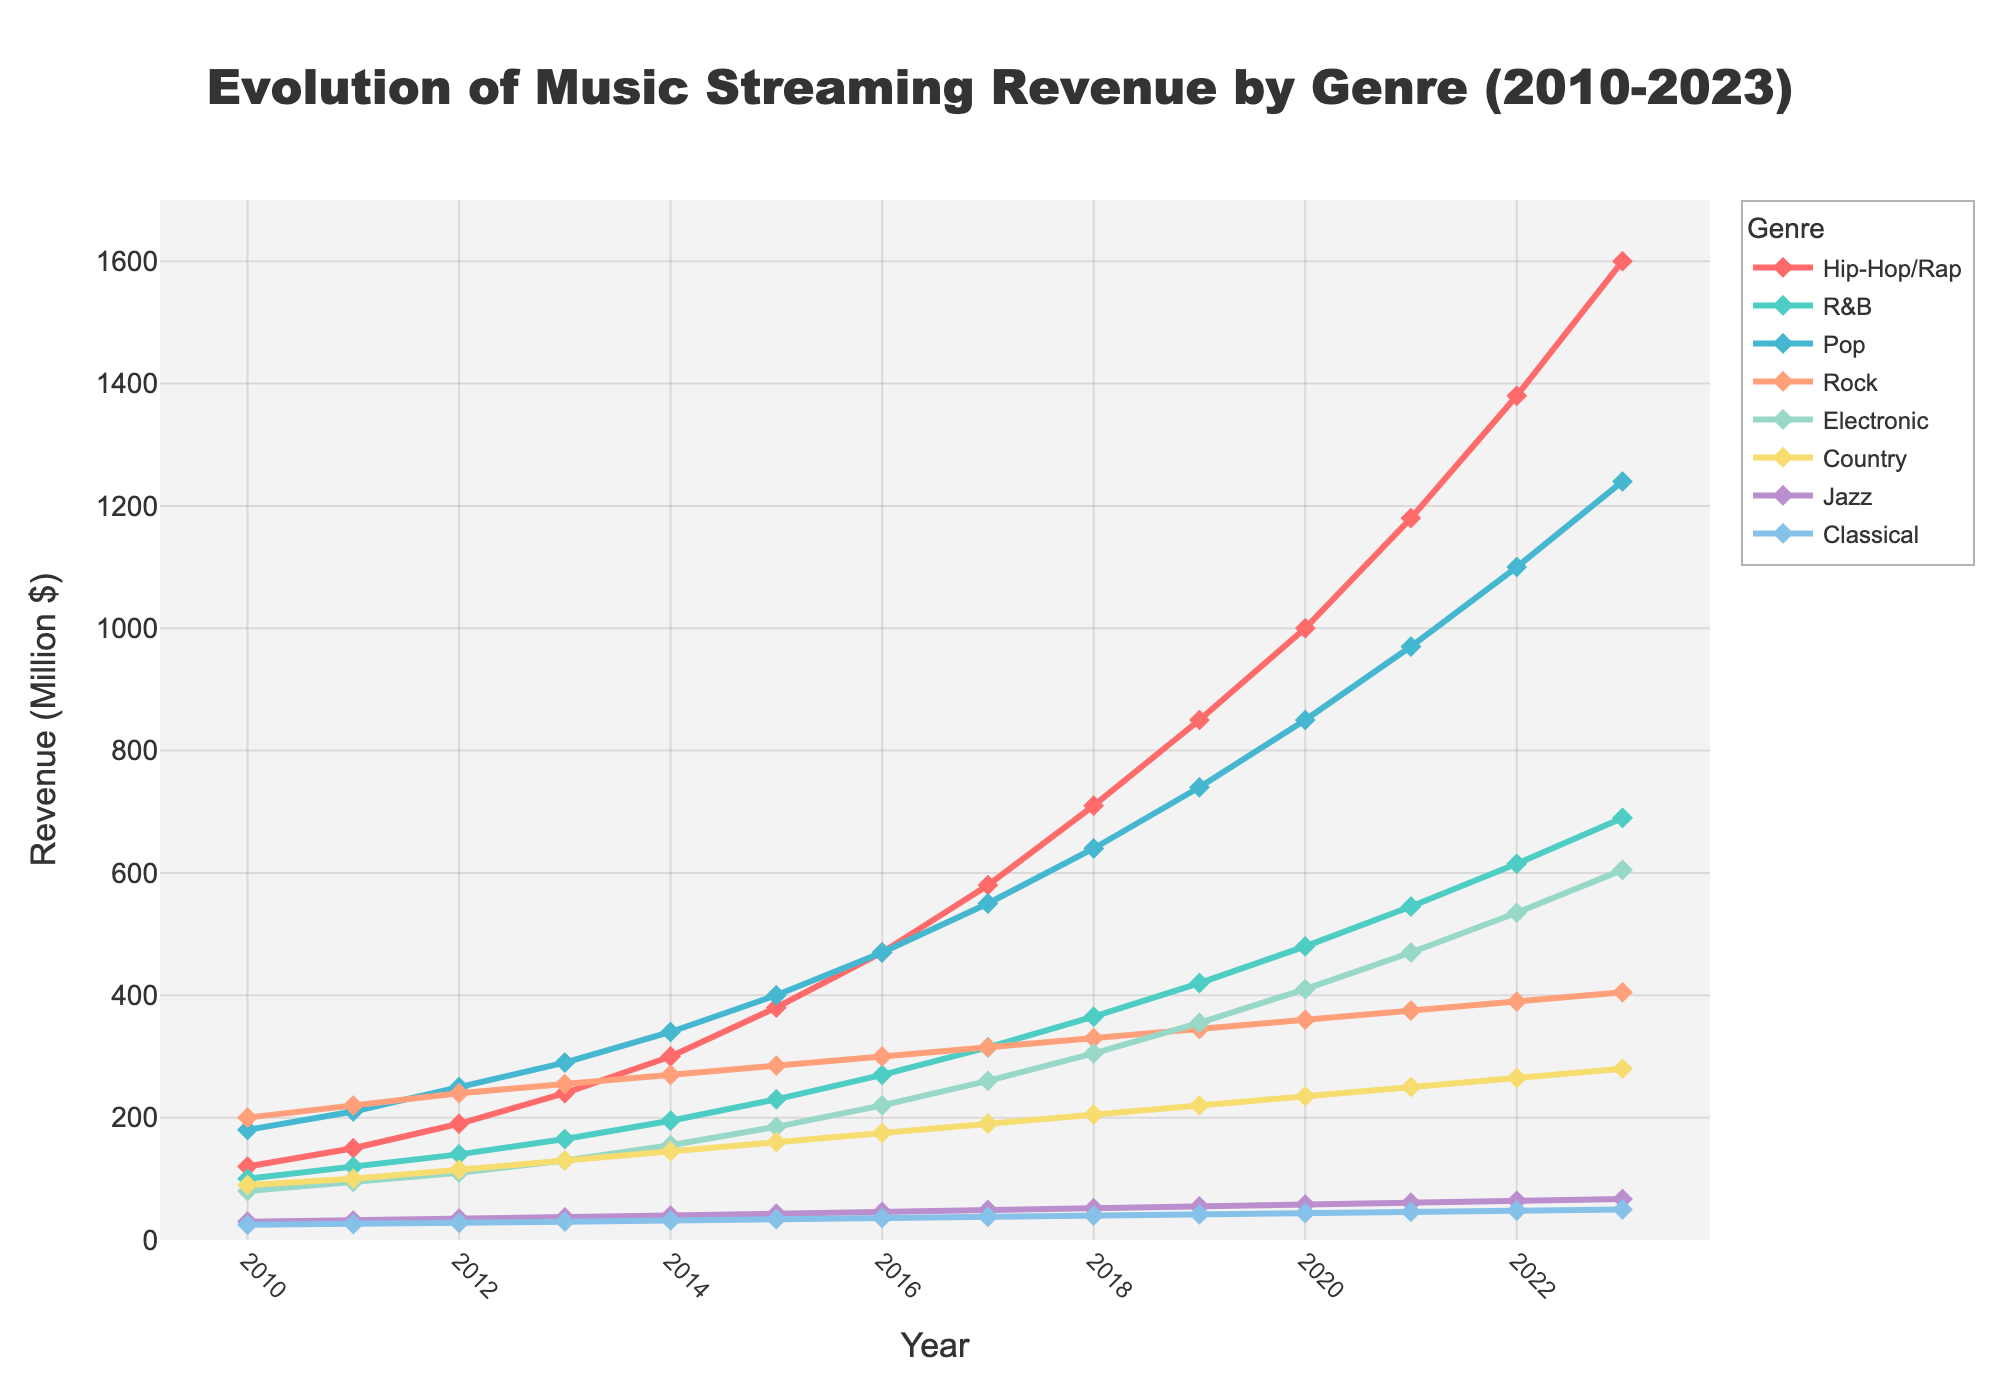Which genre had the highest revenue in 2023? By looking at the figure for 2023, observe which line reaches the highest point. Hip-Hop/Rap's line is the highest.
Answer: Hip-Hop/Rap Which genre showed the most significant increase in revenue from 2010 to 2023? Compare the 2010 and 2023 data points for each genre to find the largest difference. Hip-Hop/Rap increased from 120 million to 1600 million dollars, the largest of any genre.
Answer: Hip-Hop/Rap How did the revenue of Rock music change between 2017 and 2019? Compare the Rock genre's revenue at 2017 and 2019. In 2017 it was 315 million, and in 2019 it was 345 million.
Answer: Increased by 30 million What is the average revenue of Pop music over the years 2010, 2015, and 2020? Calculate (180 + 400 + 850) / 3. Sum is 1430 and division by 3 results in approximately 476.67.
Answer: Approximately 476.67 million dollars Which genre had the smallest revenue in 2010? Look for the lowest line or point in 2010. Classical had the smallest revenue at 25 million dollars.
Answer: Classical In which year did Electronic music first surpass a revenue of 500 million dollars? Observe the points on the Electronic genre's line. It surpasses 500 million dollars in 2022 for the first time.
Answer: 2022 Compare the revenue growth of R&B and Country from 2010 to 2023. Which genre had a higher absolute increase? Calculate the difference for R&B (690 - 100 = 590) and for Country (280 - 90 = 190).
Answer: R&B What is the combined revenue of Jazz and Classical music in 2021? Add the revenues of Jazz (61) and Classical (46) in 2021. 61 + 46 = 107 million dollars.
Answer: 107 million dollars When did Hip-Hop/Rap exceed 1000 million dollars in revenue, and what was its revenue in that year? Look for the year where Hip-Hop/Rap first exceeds 1000 million dollars, which is 2020. Revenue in 2020 was exactly 1000 million dollars.
Answer: 2020, 1000 million dollars Which genre's revenue remained below 70 million dollars throughout the entire period from 2010 to 2023? Identify the genre whose revenue never reaches 70 million. This is Classical, staying below 70 million dollars each year.
Answer: Classical 